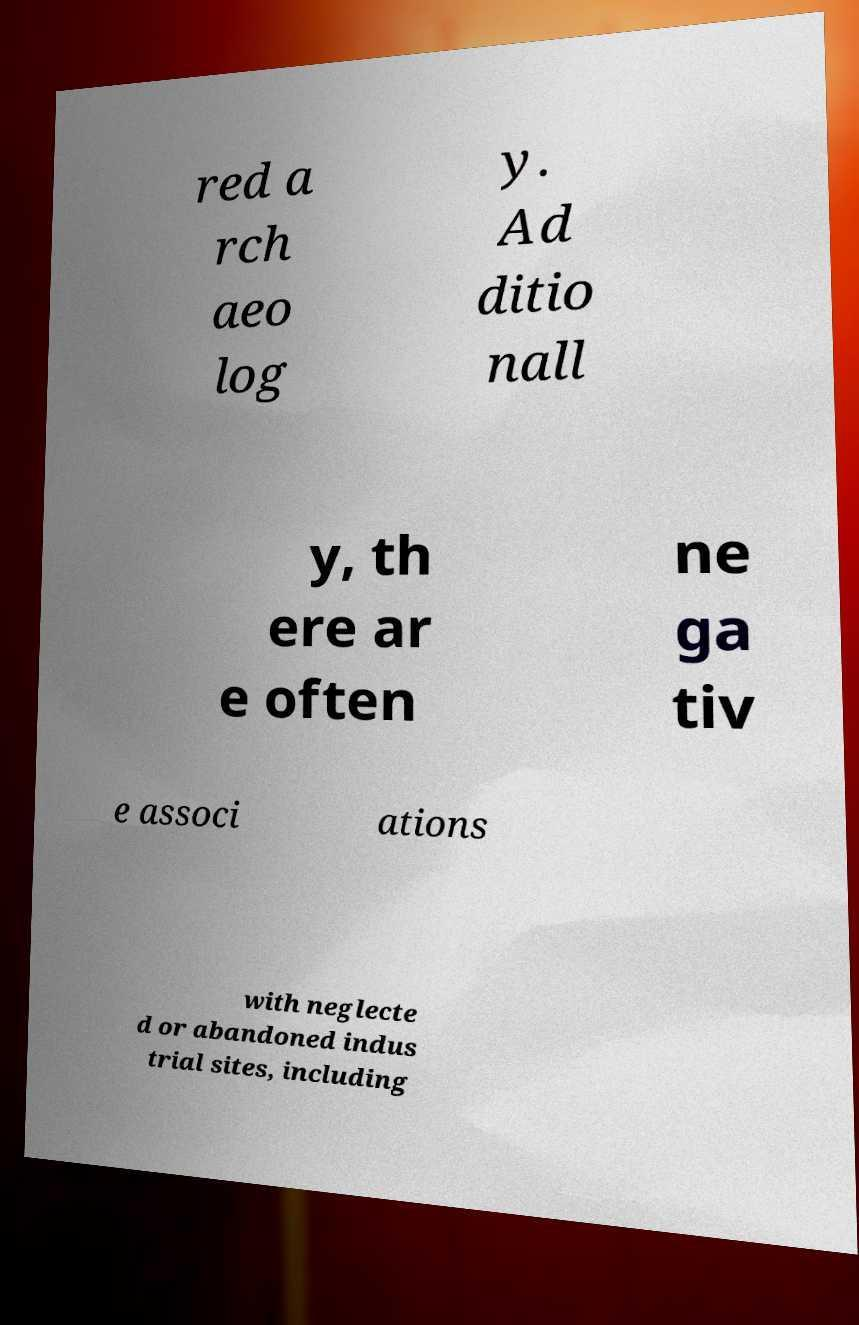There's text embedded in this image that I need extracted. Can you transcribe it verbatim? red a rch aeo log y. Ad ditio nall y, th ere ar e often ne ga tiv e associ ations with neglecte d or abandoned indus trial sites, including 